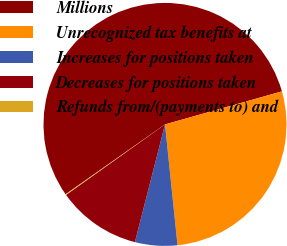Convert chart to OTSL. <chart><loc_0><loc_0><loc_500><loc_500><pie_chart><fcel>Millions<fcel>Unrecognized tax benefits at<fcel>Increases for positions taken<fcel>Decreases for positions taken<fcel>Refunds from/(payments to) and<nl><fcel>55.36%<fcel>27.74%<fcel>5.63%<fcel>11.16%<fcel>0.11%<nl></chart> 